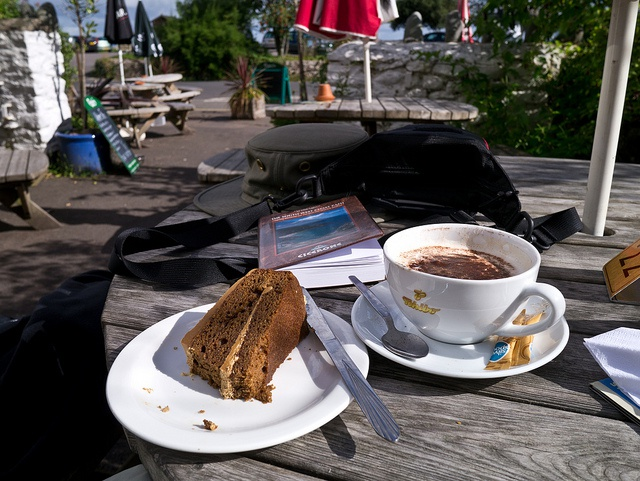Describe the objects in this image and their specific colors. I can see dining table in darkgreen, gray, black, and darkgray tones, handbag in olive, black, and gray tones, cup in olive, darkgray, lightgray, gray, and maroon tones, cake in olive, maroon, brown, and black tones, and book in olive, lavender, and gray tones in this image. 